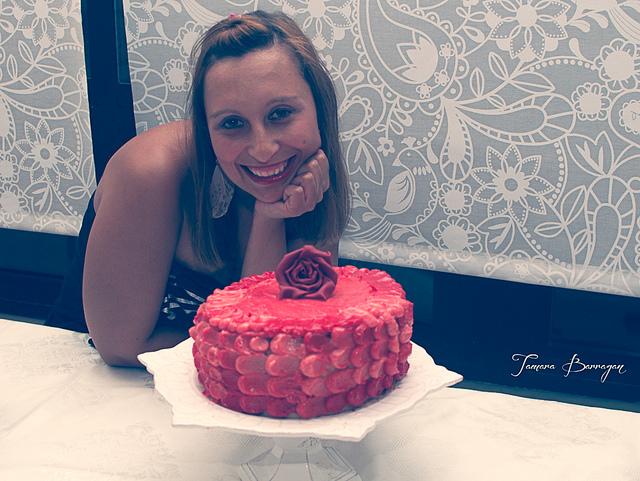What is on the top of her cake?
Keep it brief. Rose. What color is the cake?
Concise answer only. Red. Is this cake made out of hot dogs?
Write a very short answer. No. 